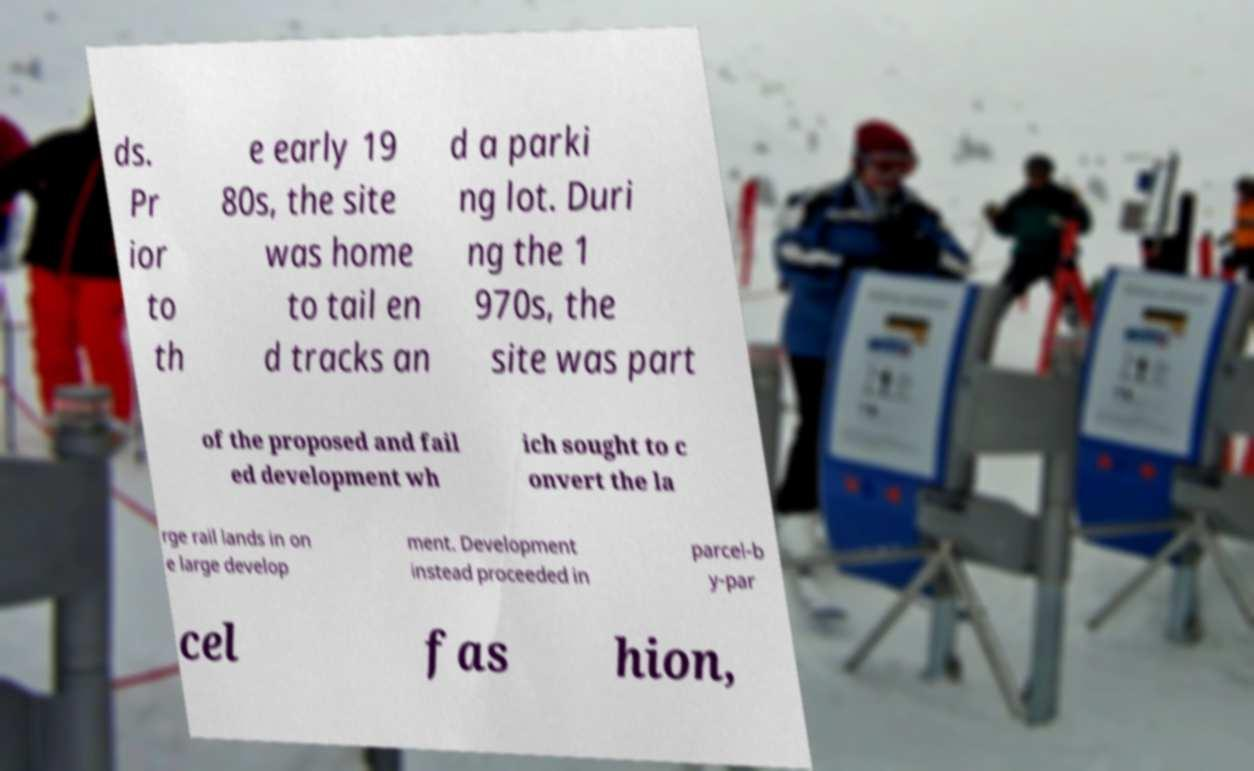There's text embedded in this image that I need extracted. Can you transcribe it verbatim? ds. Pr ior to th e early 19 80s, the site was home to tail en d tracks an d a parki ng lot. Duri ng the 1 970s, the site was part of the proposed and fail ed development wh ich sought to c onvert the la rge rail lands in on e large develop ment. Development instead proceeded in parcel-b y-par cel fas hion, 